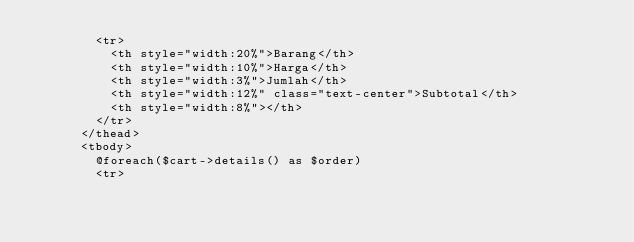Convert code to text. <code><loc_0><loc_0><loc_500><loc_500><_PHP_>        <tr>
          <th style="width:20%">Barang</th>
          <th style="width:10%">Harga</th>
          <th style="width:3%">Jumlah</th>
          <th style="width:12%" class="text-center">Subtotal</th>
          <th style="width:8%"></th>
        </tr>
      </thead>
      <tbody>
        @foreach($cart->details() as $order)
        <tr></code> 